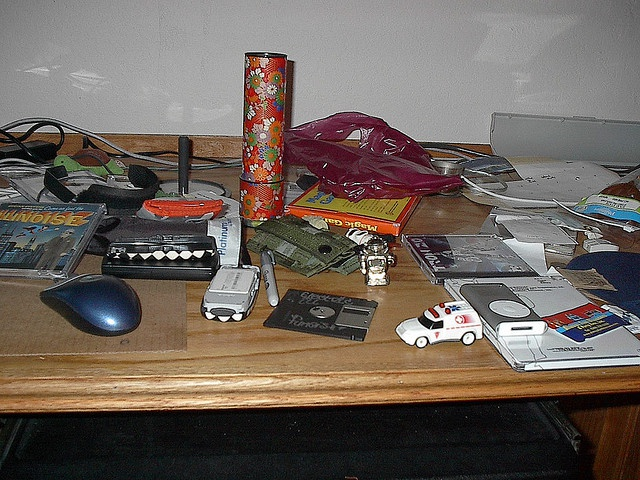Describe the objects in this image and their specific colors. I can see book in gray, black, blue, and olive tones, mouse in gray, black, navy, and blue tones, book in gray, olive, maroon, and red tones, car in gray, white, black, and darkgray tones, and remote in gray, darkgray, lightgray, and black tones in this image. 